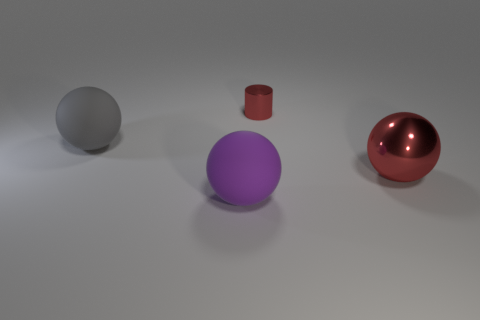If this image were part of an advertisement, what kind of products or ideas could it represent? This image, with its clean lines and simple geometric forms, could be used to advertise a variety of minimalist products, such as modern home decor, high-end technological devices, or even a branding concept emphasizing clarity, precision, and elegance. 